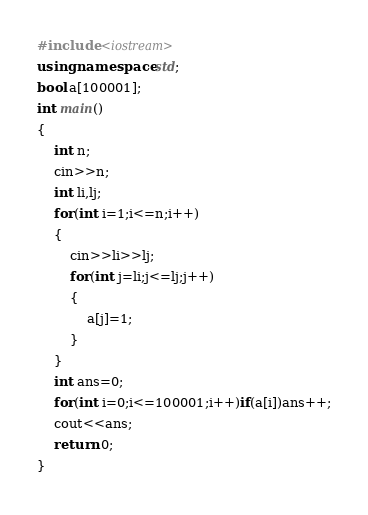Convert code to text. <code><loc_0><loc_0><loc_500><loc_500><_C++_>#include <iostream>
using namespace std;
bool a[100001];
int main()
{
	int n;
	cin>>n;
	int li,lj;
	for(int i=1;i<=n;i++)
	{
		cin>>li>>lj;
		for(int j=li;j<=lj;j++)
		{
			a[j]=1;
		}
	}
	int ans=0;
	for(int i=0;i<=100001;i++)if(a[i])ans++;
	cout<<ans;
	return 0;
}</code> 